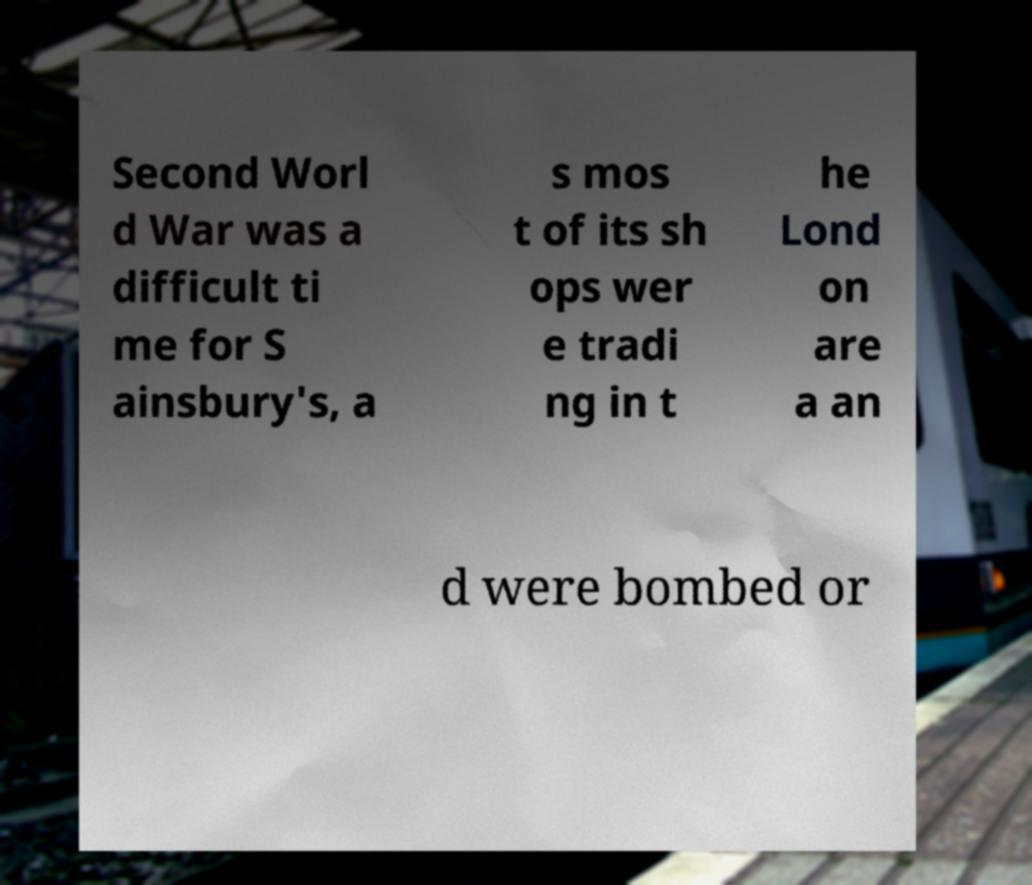Could you assist in decoding the text presented in this image and type it out clearly? Second Worl d War was a difficult ti me for S ainsbury's, a s mos t of its sh ops wer e tradi ng in t he Lond on are a an d were bombed or 